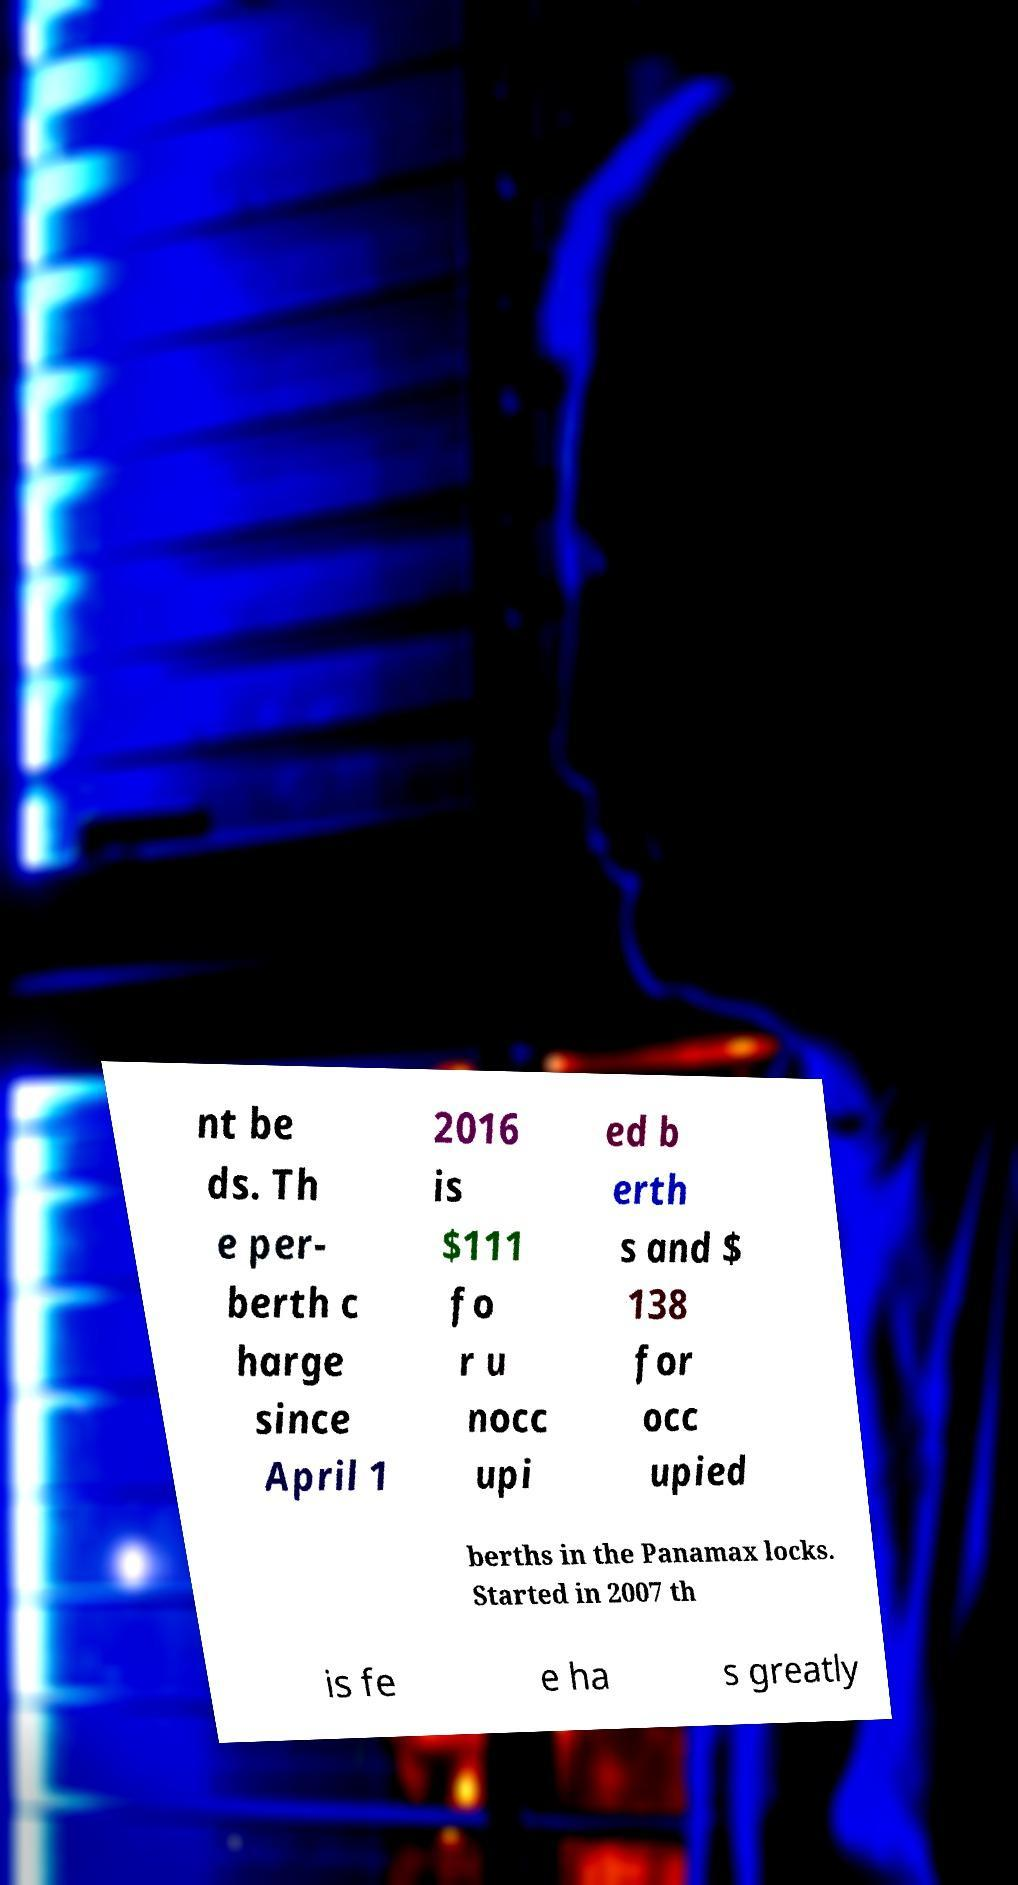What messages or text are displayed in this image? I need them in a readable, typed format. nt be ds. Th e per- berth c harge since April 1 2016 is $111 fo r u nocc upi ed b erth s and $ 138 for occ upied berths in the Panamax locks. Started in 2007 th is fe e ha s greatly 